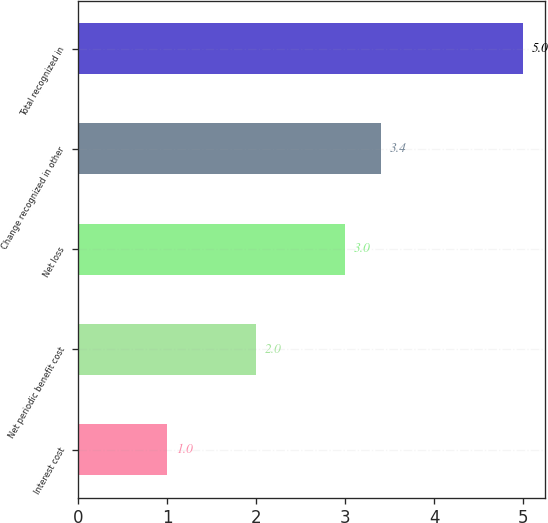<chart> <loc_0><loc_0><loc_500><loc_500><bar_chart><fcel>Interest cost<fcel>Net periodic benefit cost<fcel>Net loss<fcel>Change recognized in other<fcel>Total recognized in<nl><fcel>1<fcel>2<fcel>3<fcel>3.4<fcel>5<nl></chart> 